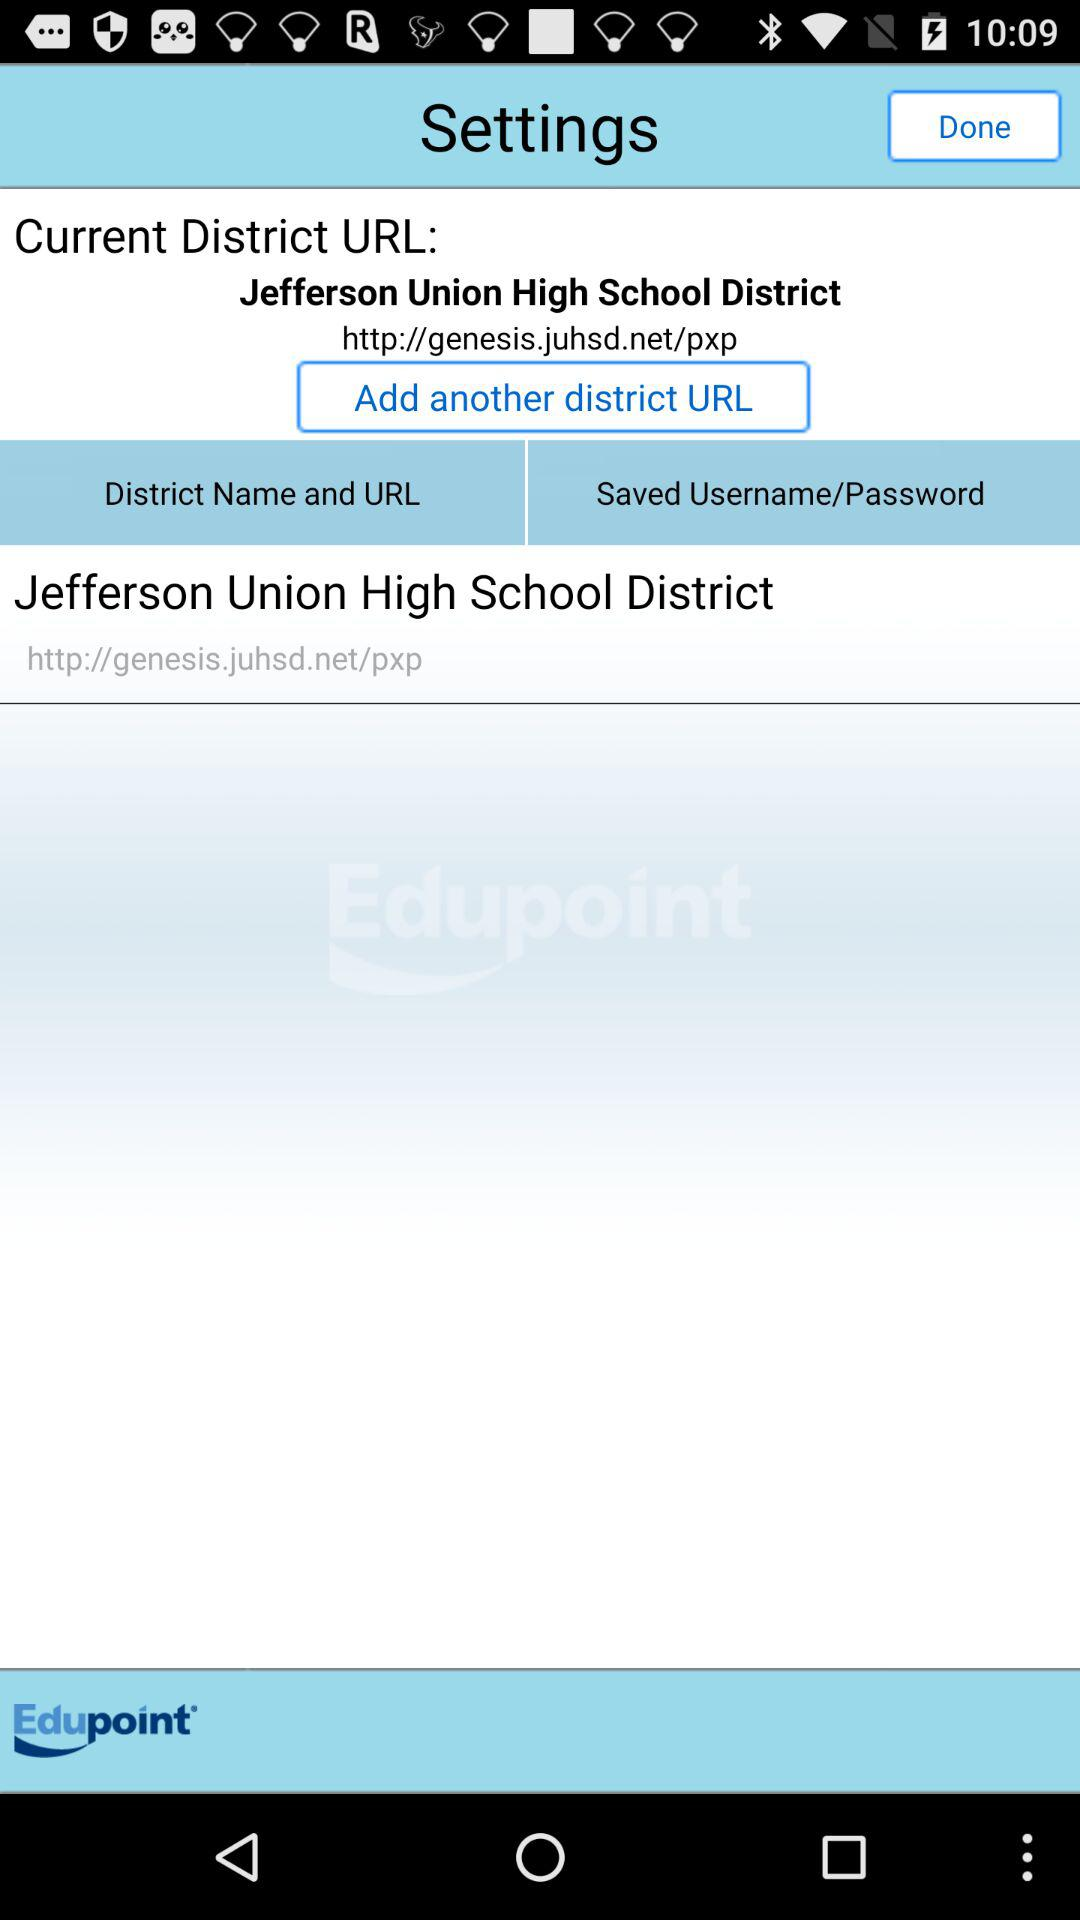What is the application name? The application name is "Edupoint". 